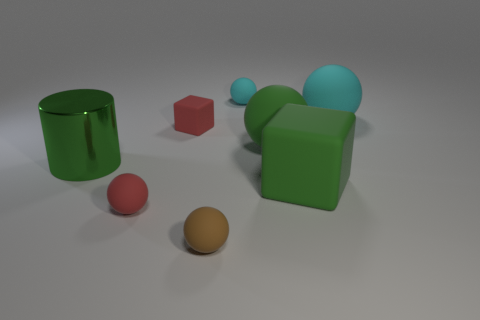Add 1 big green balls. How many objects exist? 9 Subtract all brown rubber balls. How many balls are left? 4 Subtract all green cylinders. How many cyan balls are left? 2 Subtract all red balls. How many balls are left? 4 Subtract all blocks. How many objects are left? 6 Subtract 2 cubes. How many cubes are left? 0 Subtract all tiny rubber objects. Subtract all tiny red rubber balls. How many objects are left? 3 Add 7 shiny cylinders. How many shiny cylinders are left? 8 Add 2 yellow shiny objects. How many yellow shiny objects exist? 2 Subtract 0 gray cylinders. How many objects are left? 8 